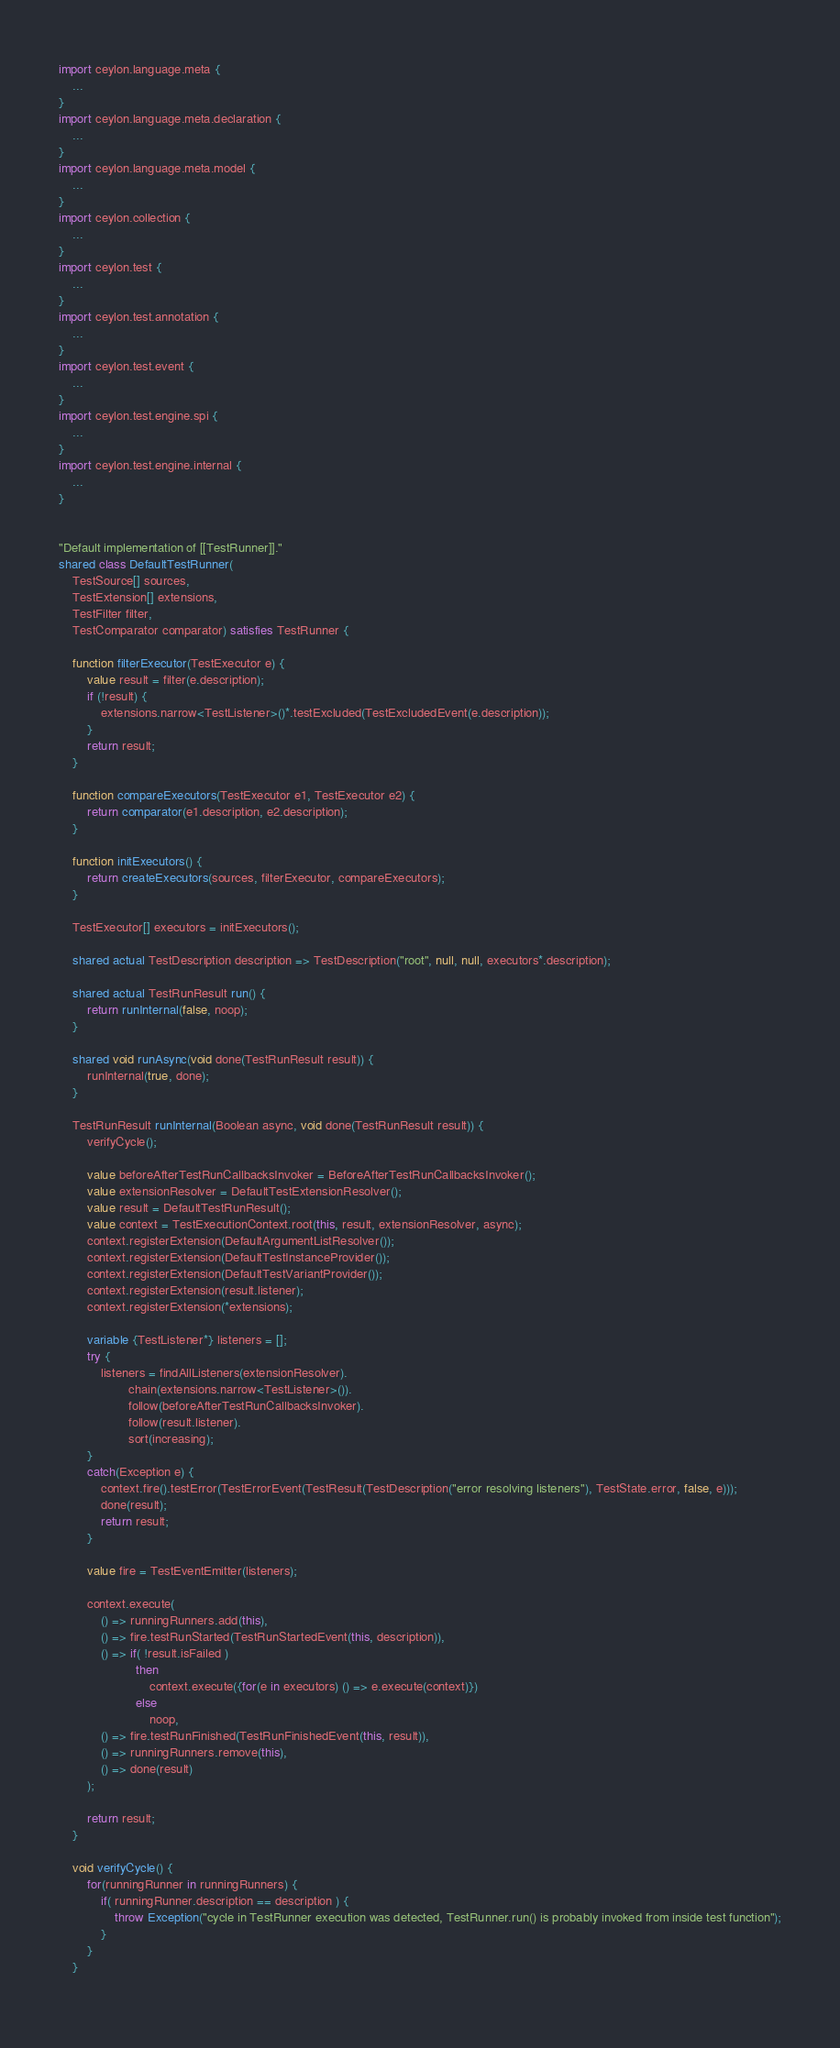Convert code to text. <code><loc_0><loc_0><loc_500><loc_500><_Ceylon_>import ceylon.language.meta {
    ...
}
import ceylon.language.meta.declaration {
    ...
}
import ceylon.language.meta.model {
    ...
}
import ceylon.collection {
    ...
}
import ceylon.test {
    ...
}
import ceylon.test.annotation {
    ...
}
import ceylon.test.event {
    ...
}
import ceylon.test.engine.spi {
    ...
}
import ceylon.test.engine.internal {
    ...
}


"Default implementation of [[TestRunner]]."
shared class DefaultTestRunner(
    TestSource[] sources,
    TestExtension[] extensions,
    TestFilter filter,
    TestComparator comparator) satisfies TestRunner {
    
    function filterExecutor(TestExecutor e) {
        value result = filter(e.description);
        if (!result) {
            extensions.narrow<TestListener>()*.testExcluded(TestExcludedEvent(e.description));
        }
        return result;
    }
    
    function compareExecutors(TestExecutor e1, TestExecutor e2) {
        return comparator(e1.description, e2.description);
    }
    
    function initExecutors() {
        return createExecutors(sources, filterExecutor, compareExecutors);
    }
    
    TestExecutor[] executors = initExecutors();
    
    shared actual TestDescription description => TestDescription("root", null, null, executors*.description);
    
    shared actual TestRunResult run() {
        return runInternal(false, noop);
    }
    
    shared void runAsync(void done(TestRunResult result)) {
        runInternal(true, done);
    }
    
    TestRunResult runInternal(Boolean async, void done(TestRunResult result)) {
        verifyCycle();
        
        value beforeAfterTestRunCallbacksInvoker = BeforeAfterTestRunCallbacksInvoker(); 
        value extensionResolver = DefaultTestExtensionResolver();
        value result = DefaultTestRunResult();
        value context = TestExecutionContext.root(this, result, extensionResolver, async);
        context.registerExtension(DefaultArgumentListResolver());
        context.registerExtension(DefaultTestInstanceProvider());
        context.registerExtension(DefaultTestVariantProvider());
        context.registerExtension(result.listener);
        context.registerExtension(*extensions);
        
        variable {TestListener*} listeners = [];
        try {
            listeners = findAllListeners(extensionResolver).
                    chain(extensions.narrow<TestListener>()).
                    follow(beforeAfterTestRunCallbacksInvoker).
                    follow(result.listener).
                    sort(increasing);
        }
        catch(Exception e) {
            context.fire().testError(TestErrorEvent(TestResult(TestDescription("error resolving listeners"), TestState.error, false, e)));
            done(result);
            return result;
        }
        
        value fire = TestEventEmitter(listeners);        
        
        context.execute(
            () => runningRunners.add(this),
            () => fire.testRunStarted(TestRunStartedEvent(this, description)),
            () => if( !result.isFailed )
                      then
                          context.execute({for(e in executors) () => e.execute(context)}) 
                      else 
                          noop,
            () => fire.testRunFinished(TestRunFinishedEvent(this, result)),
            () => runningRunners.remove(this),
            () => done(result)
        );       
        
        return result;
    }
    
    void verifyCycle() {
        for(runningRunner in runningRunners) {
            if( runningRunner.description == description ) {
                throw Exception("cycle in TestRunner execution was detected, TestRunner.run() is probably invoked from inside test function");
            }
        }
    }
    </code> 